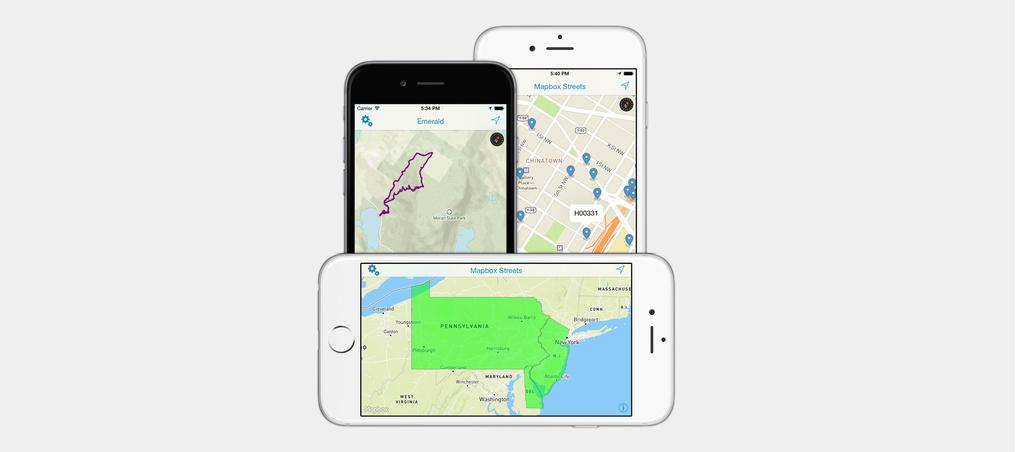<image>
Summarize the visual content of the image. A map of Pennsylvania is on the screen of a white cell phone. 